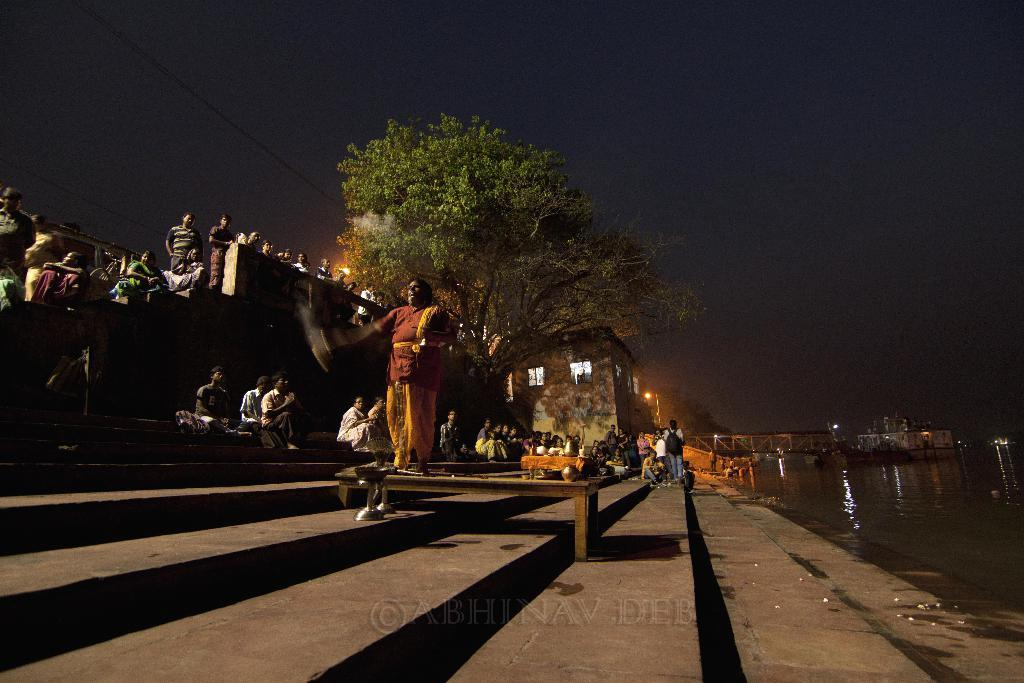What are the people in the image doing? There are many people sitting on the steps in the image. Where are the steps located? The steps are located at the river bank. What can be seen on the right side of the image? There is a river on the right side of the image. What is in the background of the image? There is a huge tree and lights visible in the background of the image. What type of lizards can be seen crawling on the steps in the image? There are no lizards present in the image; it only shows people sitting on the steps. What is being mined in the background of the image? There is no mine or mining activity visible in the image; it features a river, a tree, and lights in the background. 